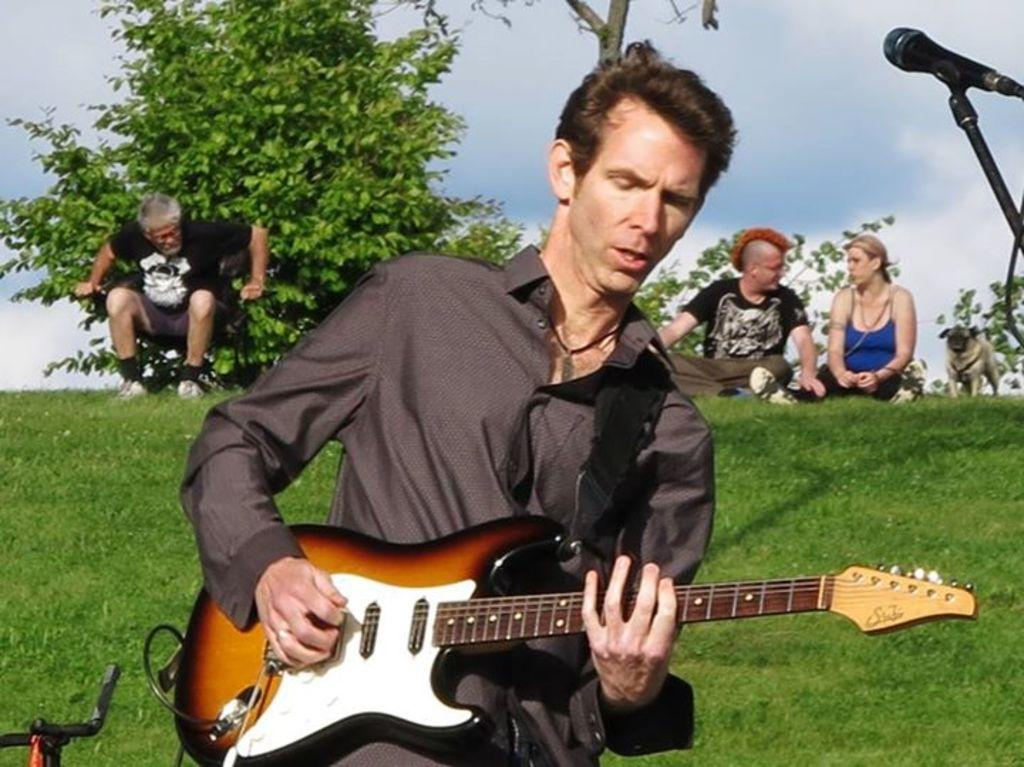What can be seen in the sky in the image? The sky is visible in the image, but no specific details about the sky can be determined from the provided facts. What object is present in the image that is commonly used for amplifying sound? There is a microphone (mic) in the image. What type of plant is present in the image? There is a tree in the image. Who is present in the image? There is a man in the image. What is the man holding in the image? The man is holding a guitar. What type of news is being reported by the man holding the guitar in the image? There is no indication in the image that the man is reporting news, as he is holding a guitar instead of a microphone or other news-related equipment. What type of powder is being used by the beginner in the image? There is no beginner or powder present in the image. 